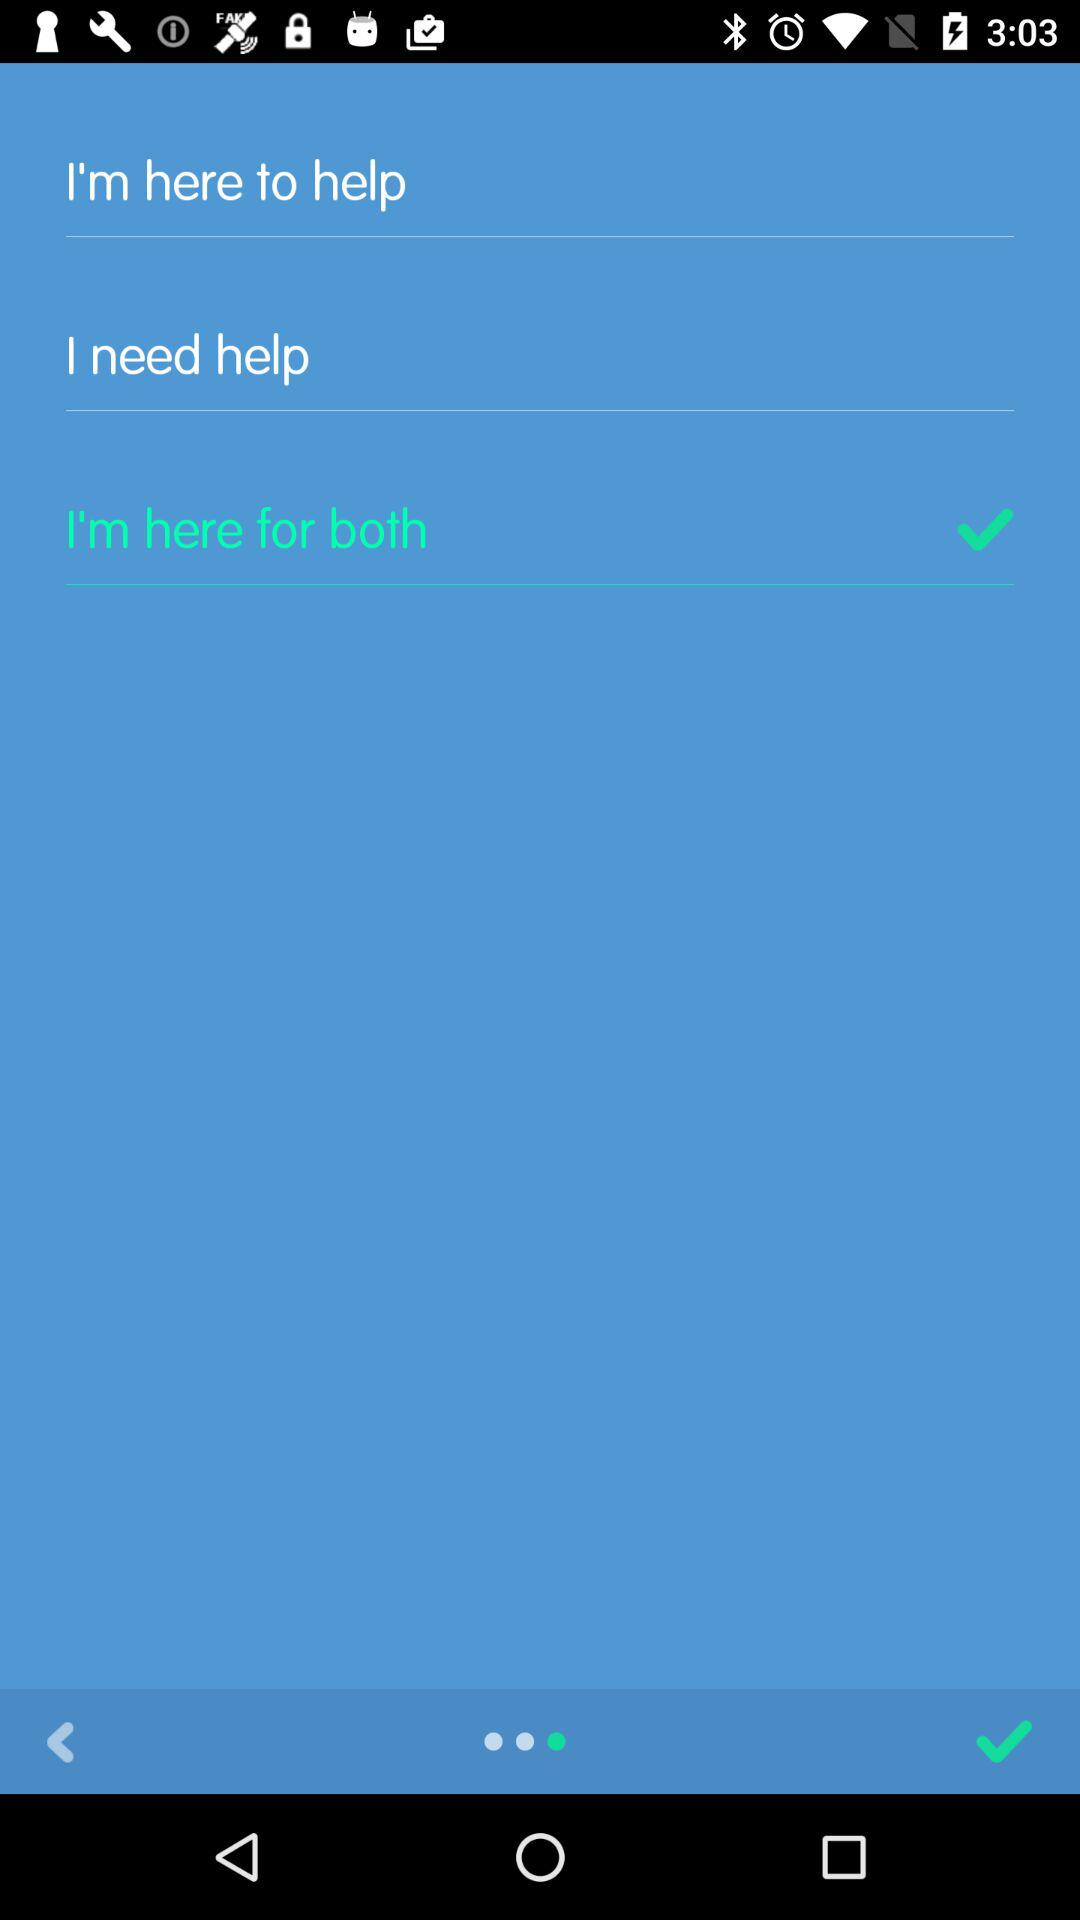What is the selected option? The selected option is "I'm here for both". 